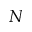<formula> <loc_0><loc_0><loc_500><loc_500>N</formula> 